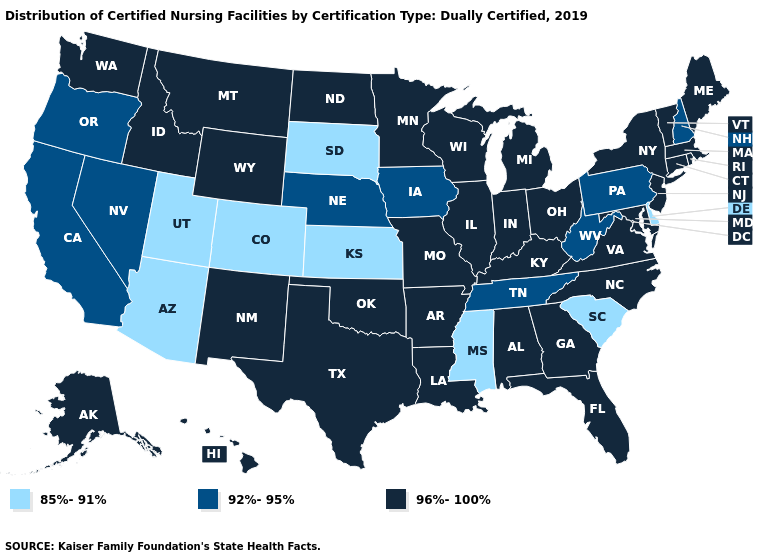Does Kansas have the lowest value in the USA?
Quick response, please. Yes. Does New Mexico have a higher value than Wisconsin?
Answer briefly. No. Which states have the highest value in the USA?
Keep it brief. Alabama, Alaska, Arkansas, Connecticut, Florida, Georgia, Hawaii, Idaho, Illinois, Indiana, Kentucky, Louisiana, Maine, Maryland, Massachusetts, Michigan, Minnesota, Missouri, Montana, New Jersey, New Mexico, New York, North Carolina, North Dakota, Ohio, Oklahoma, Rhode Island, Texas, Vermont, Virginia, Washington, Wisconsin, Wyoming. Does North Dakota have the same value as Mississippi?
Short answer required. No. Name the states that have a value in the range 92%-95%?
Give a very brief answer. California, Iowa, Nebraska, Nevada, New Hampshire, Oregon, Pennsylvania, Tennessee, West Virginia. Among the states that border Texas , which have the lowest value?
Short answer required. Arkansas, Louisiana, New Mexico, Oklahoma. What is the value of Minnesota?
Be succinct. 96%-100%. Name the states that have a value in the range 96%-100%?
Be succinct. Alabama, Alaska, Arkansas, Connecticut, Florida, Georgia, Hawaii, Idaho, Illinois, Indiana, Kentucky, Louisiana, Maine, Maryland, Massachusetts, Michigan, Minnesota, Missouri, Montana, New Jersey, New Mexico, New York, North Carolina, North Dakota, Ohio, Oklahoma, Rhode Island, Texas, Vermont, Virginia, Washington, Wisconsin, Wyoming. Does the first symbol in the legend represent the smallest category?
Write a very short answer. Yes. What is the lowest value in states that border New York?
Be succinct. 92%-95%. Does Indiana have the highest value in the USA?
Give a very brief answer. Yes. What is the highest value in the Northeast ?
Concise answer only. 96%-100%. Which states hav the highest value in the MidWest?
Concise answer only. Illinois, Indiana, Michigan, Minnesota, Missouri, North Dakota, Ohio, Wisconsin. Does California have a lower value than Alabama?
Give a very brief answer. Yes. 